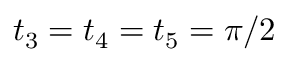Convert formula to latex. <formula><loc_0><loc_0><loc_500><loc_500>t _ { 3 } = t _ { 4 } = t _ { 5 } = \pi / 2</formula> 